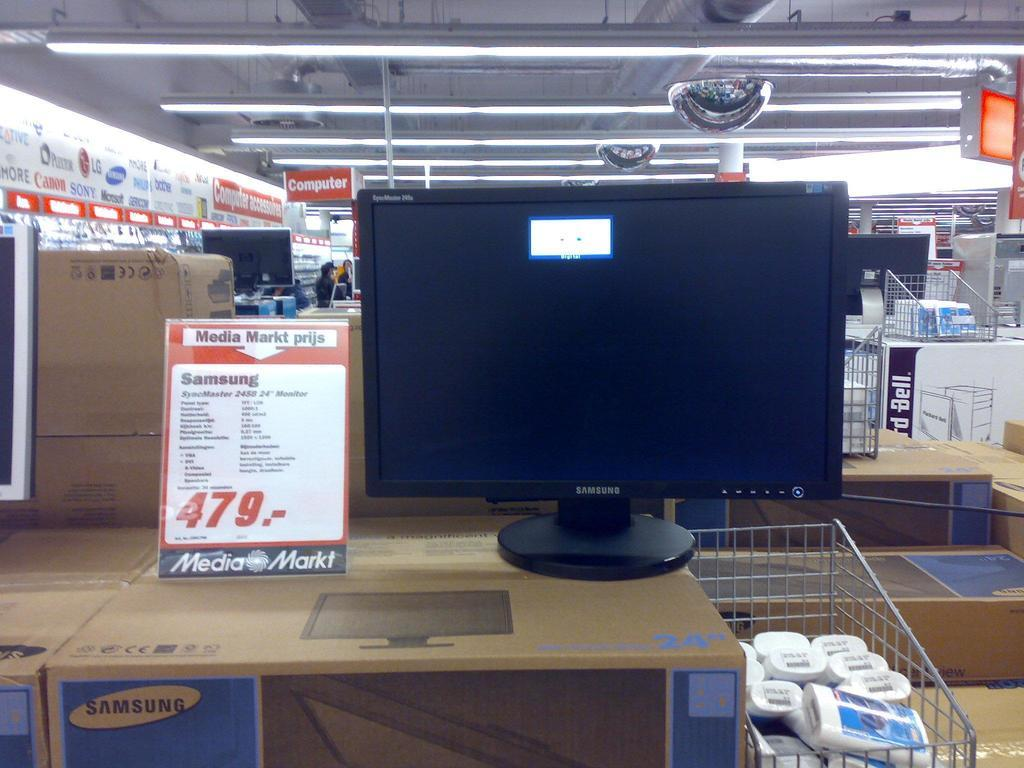<image>
Provide a brief description of the given image. A computer on display with a sign indicating a sale price of $479.00. 